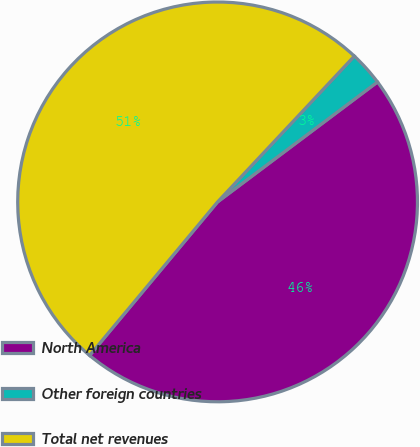Convert chart. <chart><loc_0><loc_0><loc_500><loc_500><pie_chart><fcel>North America<fcel>Other foreign countries<fcel>Total net revenues<nl><fcel>46.3%<fcel>2.77%<fcel>50.93%<nl></chart> 